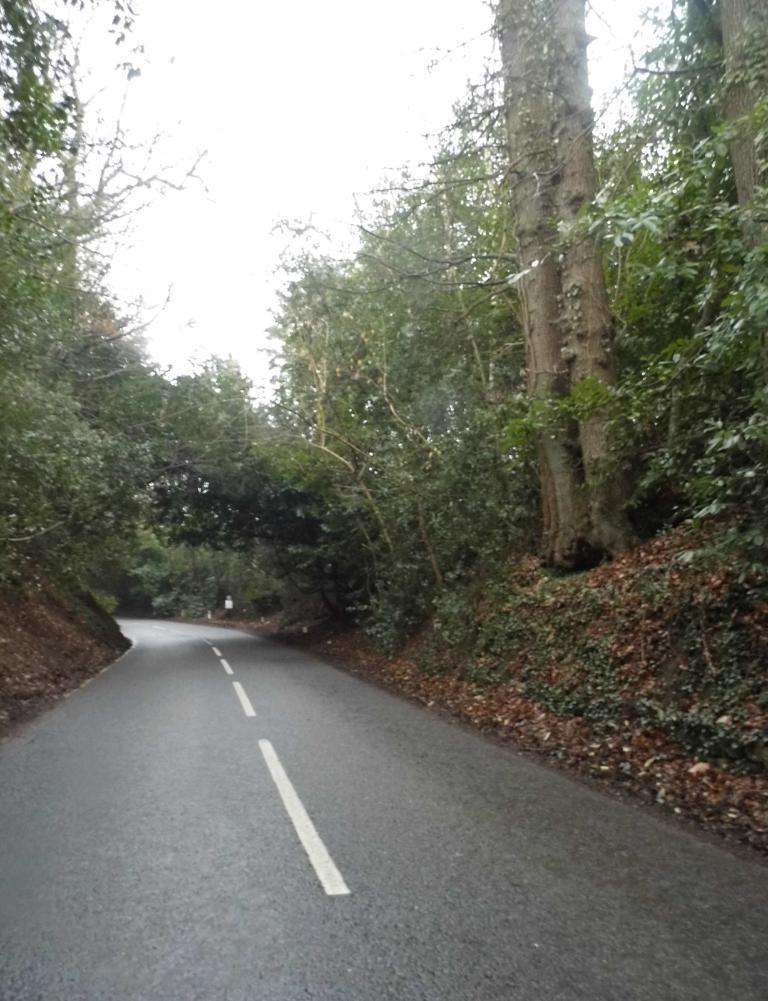What is the main feature of the image? There is a road in the image. What distinguishes the center of the road? The road has white stripes in the middle. What type of vegetation can be seen on the sides of the road? There are plants and trees on the sides of the road. What can be seen in the background of the image? There are trees and the sky visible in the background of the image. Who is the manager of the rail growth depicted in the image? There is no rail or growth present in the image, and therefore no manager can be identified. 